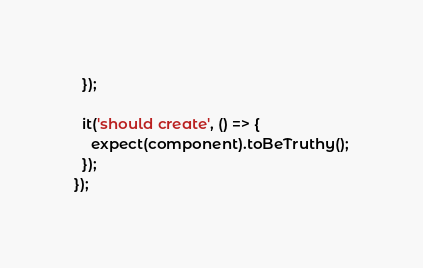<code> <loc_0><loc_0><loc_500><loc_500><_TypeScript_>  });

  it('should create', () => {
    expect(component).toBeTruthy();
  });
});
</code> 